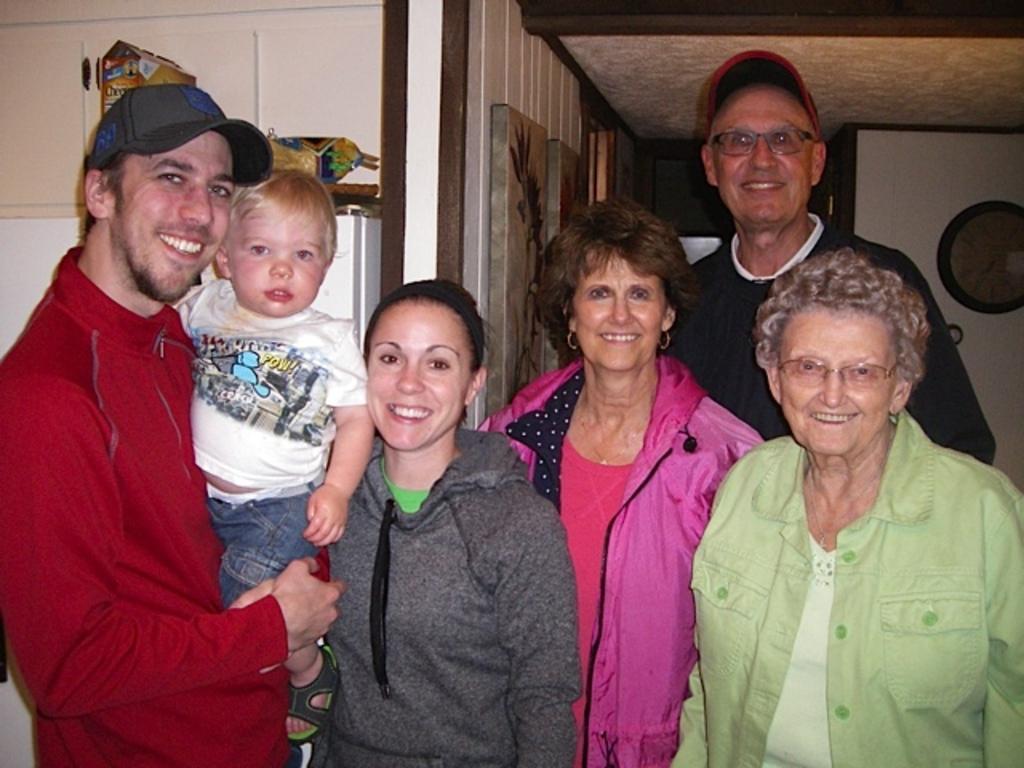Describe this image in one or two sentences. In this image I can see the group of people with different color dress. I can see two people with caps. In the background I can see the frames to the wall. And I can see the clock to the right. 